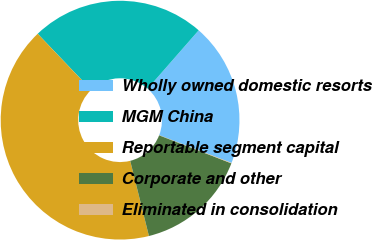Convert chart. <chart><loc_0><loc_0><loc_500><loc_500><pie_chart><fcel>Wholly owned domestic resorts<fcel>MGM China<fcel>Reportable segment capital<fcel>Corporate and other<fcel>Eliminated in consolidation<nl><fcel>19.39%<fcel>23.56%<fcel>41.76%<fcel>15.22%<fcel>0.06%<nl></chart> 